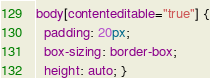Convert code to text. <code><loc_0><loc_0><loc_500><loc_500><_CSS_>body[contenteditable="true"] {
  padding: 20px;
  box-sizing: border-box;
  height: auto; }
</code> 